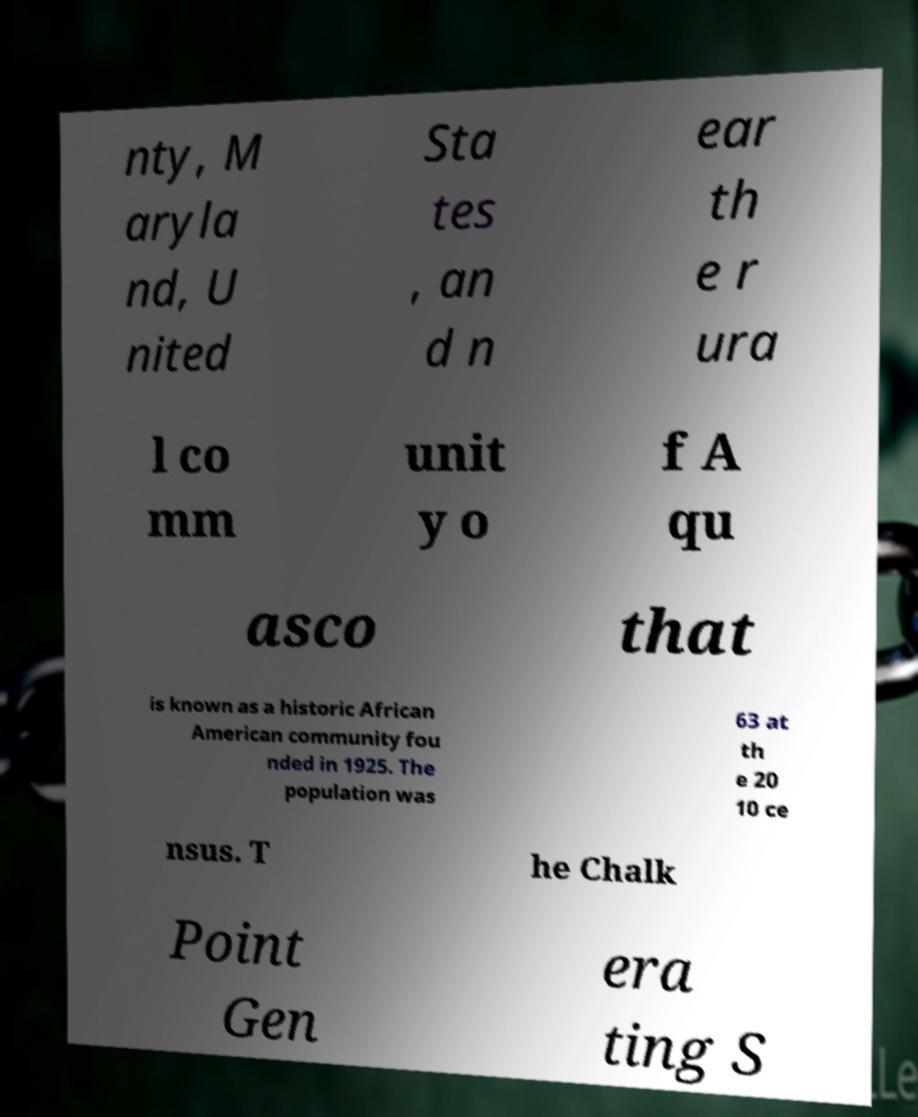Can you accurately transcribe the text from the provided image for me? nty, M aryla nd, U nited Sta tes , an d n ear th e r ura l co mm unit y o f A qu asco that is known as a historic African American community fou nded in 1925. The population was 63 at th e 20 10 ce nsus. T he Chalk Point Gen era ting S 